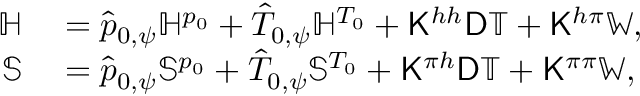<formula> <loc_0><loc_0><loc_500><loc_500>\begin{array} { r l } { \mathbb { H } } & = \hat { p } _ { 0 , \psi } \mathbb { H } ^ { p _ { 0 } } + \hat { T } _ { 0 , \psi } \mathbb { H } ^ { T _ { 0 } } + K ^ { h h } D \mathbb { T } + K ^ { h \pi } \mathbb { W } , } \\ { \mathbb { S } } & = \hat { p } _ { 0 , \psi } \mathbb { S } ^ { p _ { 0 } } + \hat { T } _ { 0 , \psi } \mathbb { S } ^ { T _ { 0 } } + K ^ { \pi h } D \mathbb { T } + K ^ { \pi \pi } \mathbb { W } , } \end{array}</formula> 